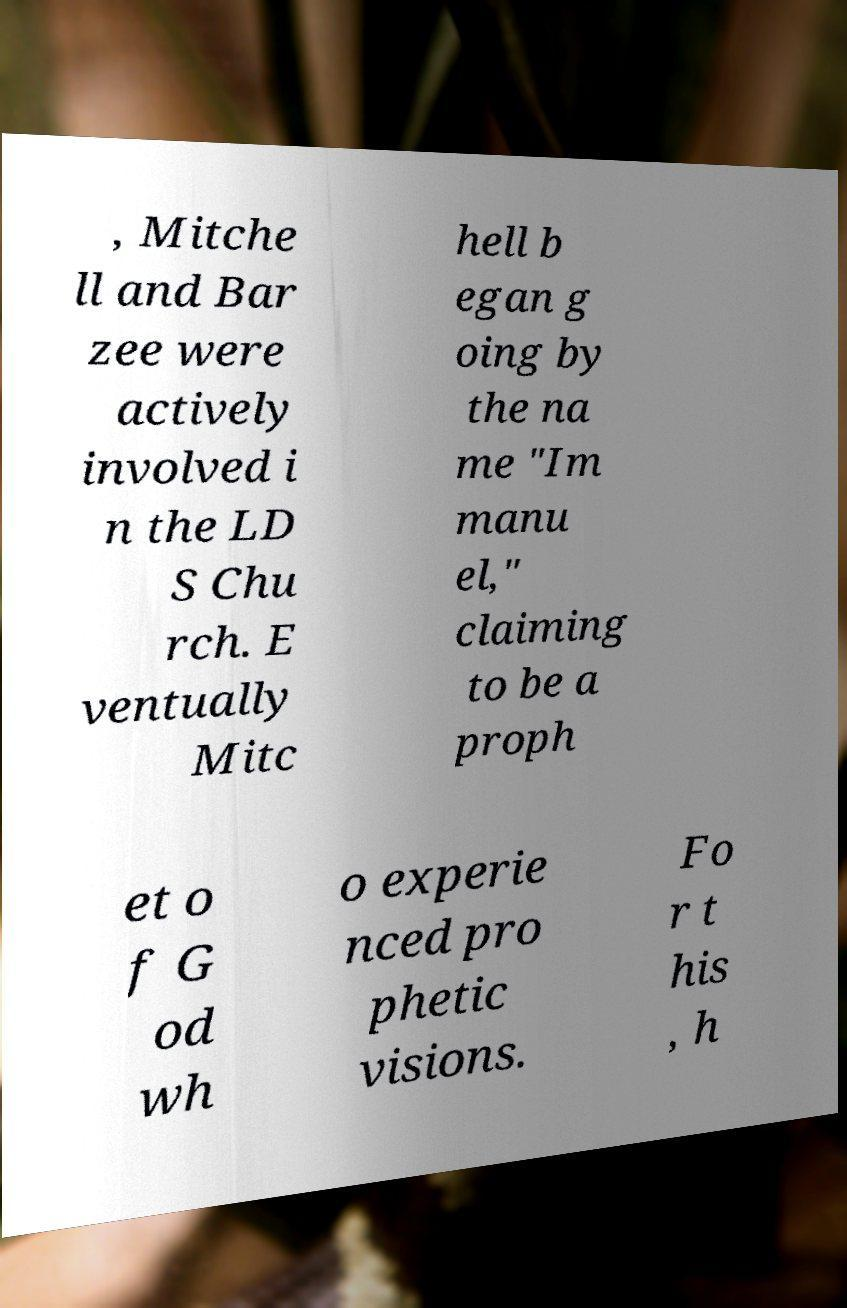Can you read and provide the text displayed in the image?This photo seems to have some interesting text. Can you extract and type it out for me? , Mitche ll and Bar zee were actively involved i n the LD S Chu rch. E ventually Mitc hell b egan g oing by the na me "Im manu el," claiming to be a proph et o f G od wh o experie nced pro phetic visions. Fo r t his , h 